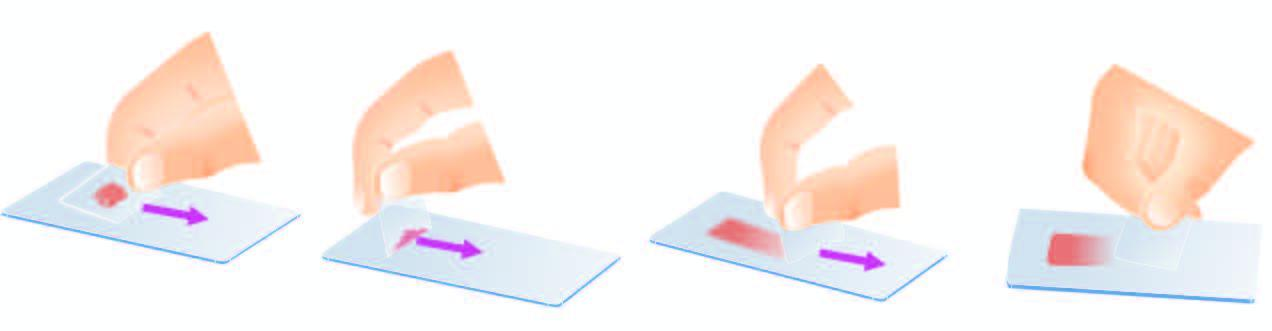what are crush-smeared by flat pressure with cover slip or glass slide?
Answer the question using a single word or phrase. Semisolid aspirates 